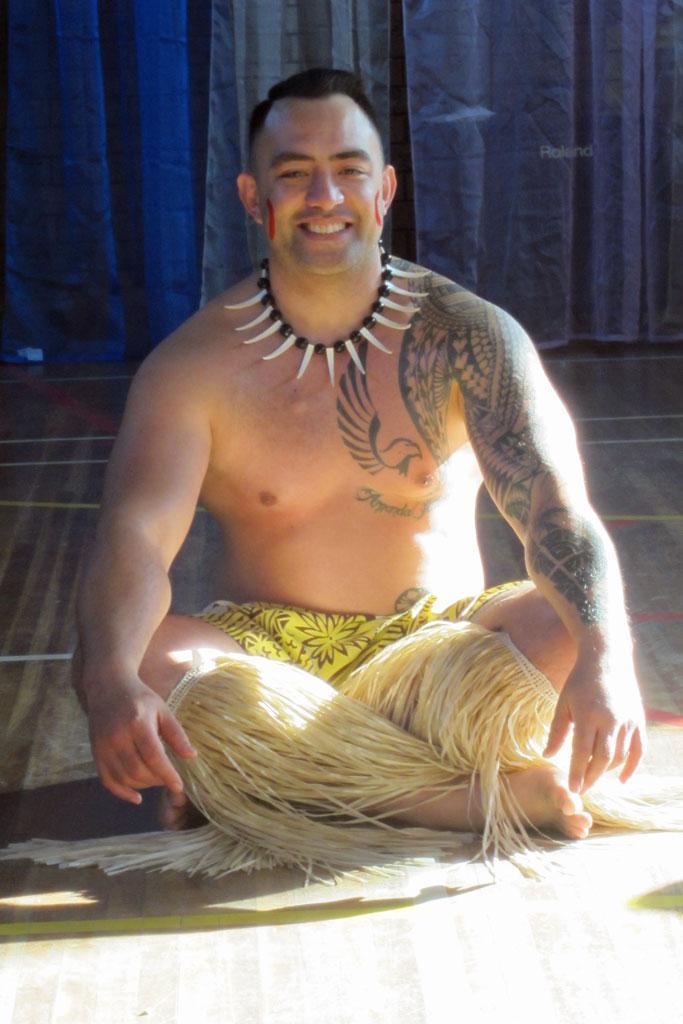Could you give a brief overview of what you see in this image? A man is sitting wearing shorts. 